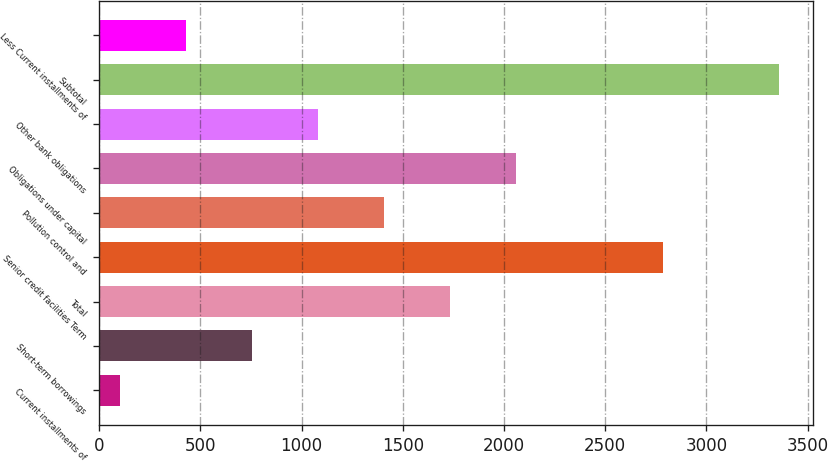Convert chart to OTSL. <chart><loc_0><loc_0><loc_500><loc_500><bar_chart><fcel>Current installments of<fcel>Short-term borrowings<fcel>Total<fcel>Senior credit facilities Term<fcel>Pollution control and<fcel>Obligations under capital<fcel>Other bank obligations<fcel>Subtotal<fcel>Less Current installments of<nl><fcel>102<fcel>753.8<fcel>1731.5<fcel>2785<fcel>1405.6<fcel>2057.4<fcel>1079.7<fcel>3361<fcel>427.9<nl></chart> 